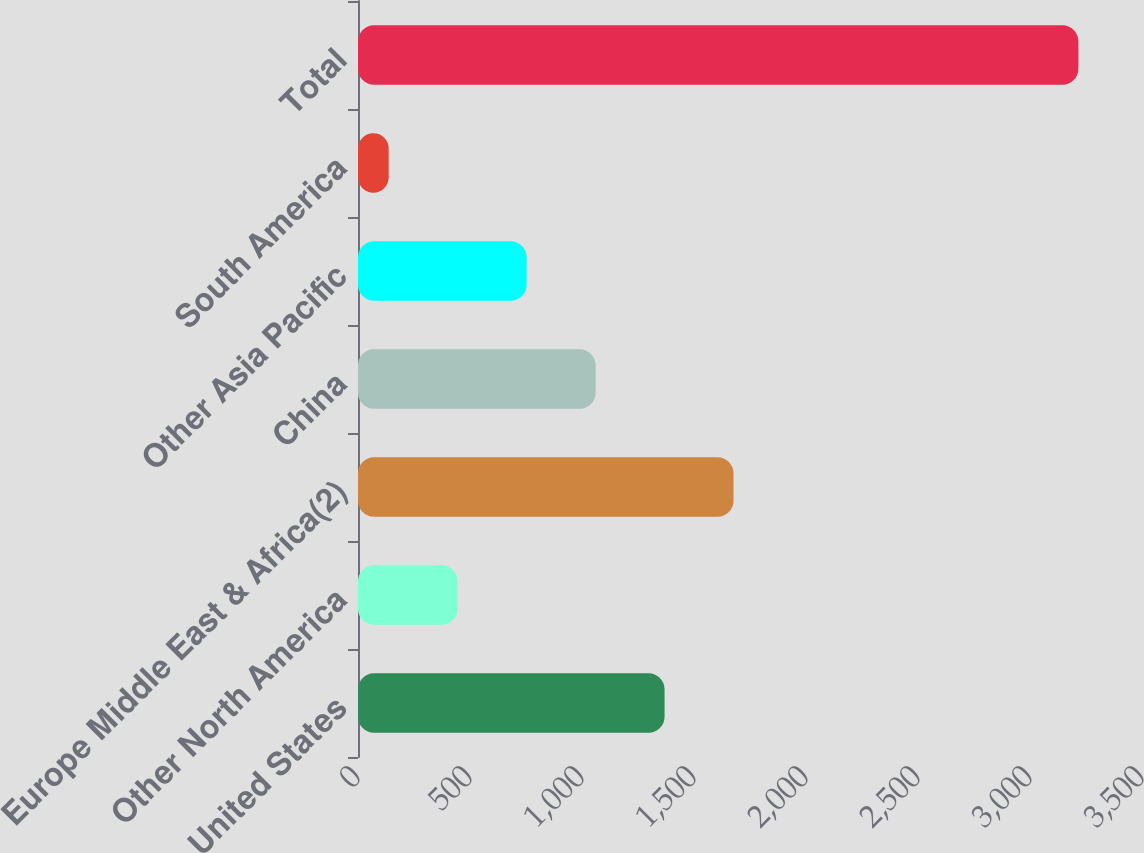Convert chart. <chart><loc_0><loc_0><loc_500><loc_500><bar_chart><fcel>United States<fcel>Other North America<fcel>Europe Middle East & Africa(2)<fcel>China<fcel>Other Asia Pacific<fcel>South America<fcel>Total<nl><fcel>1368.6<fcel>444.9<fcel>1676.5<fcel>1060.7<fcel>752.8<fcel>137<fcel>3216<nl></chart> 